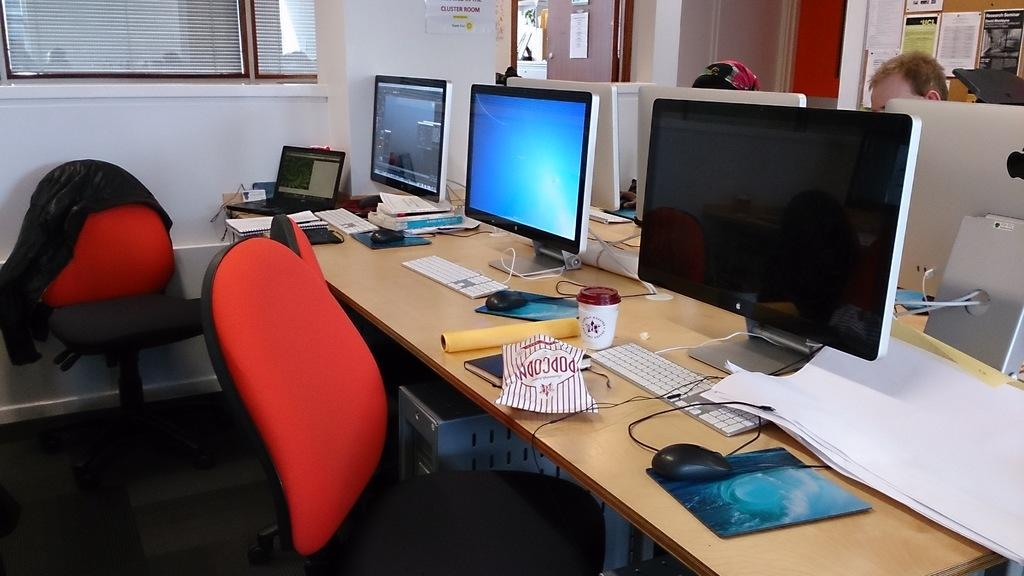<image>
Offer a succinct explanation of the picture presented. Three computer stations and the closest one has an open bag of popcorn at it. 